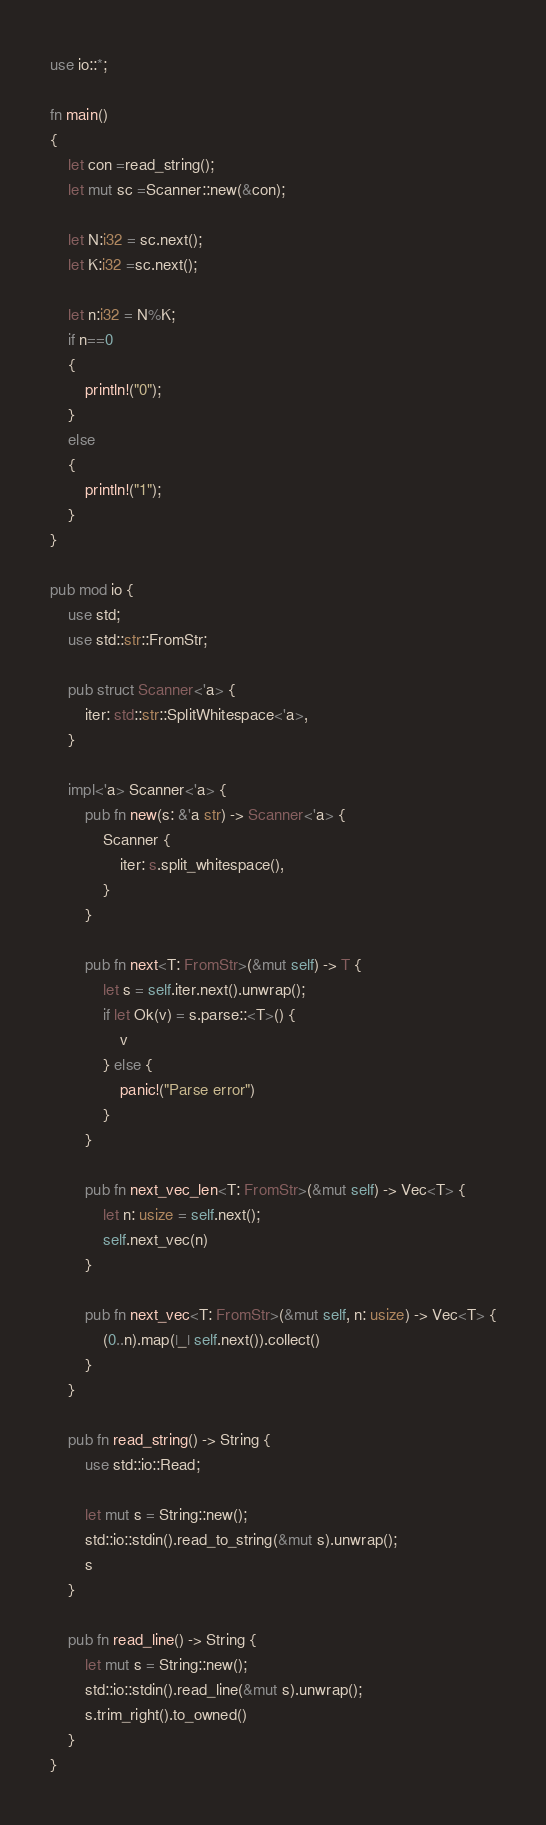<code> <loc_0><loc_0><loc_500><loc_500><_Rust_>use io::*;

fn main()
{
    let con =read_string();
    let mut sc =Scanner::new(&con);

    let N:i32 = sc.next();
    let K:i32 =sc.next();

    let n:i32 = N%K;
    if n==0
    {
        println!("0");
    }
    else
    {
        println!("1");
    }
}

pub mod io {
    use std;
    use std::str::FromStr;
 
    pub struct Scanner<'a> {
        iter: std::str::SplitWhitespace<'a>,
    }
 
    impl<'a> Scanner<'a> {
        pub fn new(s: &'a str) -> Scanner<'a> {
            Scanner {
                iter: s.split_whitespace(),
            }
        }
 
        pub fn next<T: FromStr>(&mut self) -> T {
            let s = self.iter.next().unwrap();
            if let Ok(v) = s.parse::<T>() {
                v
            } else {
                panic!("Parse error")
            }
        }
 
        pub fn next_vec_len<T: FromStr>(&mut self) -> Vec<T> {
            let n: usize = self.next();
            self.next_vec(n)
        }
 
        pub fn next_vec<T: FromStr>(&mut self, n: usize) -> Vec<T> {
            (0..n).map(|_| self.next()).collect()
        }
    }
 
    pub fn read_string() -> String {
        use std::io::Read;
 
        let mut s = String::new();
        std::io::stdin().read_to_string(&mut s).unwrap();
        s
    }
 
    pub fn read_line() -> String {
        let mut s = String::new();
        std::io::stdin().read_line(&mut s).unwrap();
        s.trim_right().to_owned()
    }
}</code> 